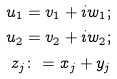<formula> <loc_0><loc_0><loc_500><loc_500>u _ { 1 } = v _ { 1 } + i w _ { 1 } ; \\ u _ { 2 } = v _ { 2 } + i w _ { 2 } ; \\ z _ { j } \colon = x _ { j } + y _ { j }</formula> 